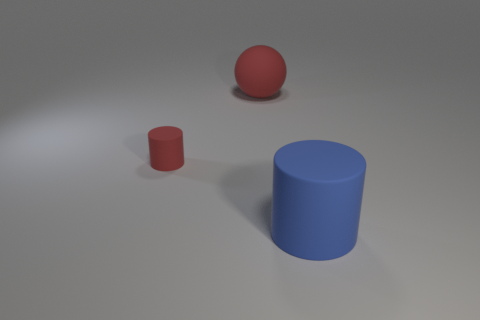Does the big cylinder have the same color as the tiny object?
Your response must be concise. No. There is a large rubber thing behind the rubber cylinder in front of the red matte cylinder; how many cylinders are right of it?
Your answer should be very brief. 1. There is a small red thing that is the same material as the sphere; what is its shape?
Keep it short and to the point. Cylinder. There is a large object behind the matte cylinder that is behind the matte cylinder that is right of the red matte ball; what is its material?
Make the answer very short. Rubber. What number of things are things on the left side of the large red rubber thing or small green shiny spheres?
Your answer should be compact. 1. What number of other things are there of the same shape as the large red matte object?
Your answer should be very brief. 0. Is the number of rubber cylinders to the left of the large ball greater than the number of tiny cyan rubber spheres?
Offer a terse response. Yes. There is another object that is the same shape as the tiny red rubber thing; what is its size?
Give a very brief answer. Large. What is the shape of the small rubber object?
Give a very brief answer. Cylinder. The blue rubber thing that is the same size as the red sphere is what shape?
Your answer should be compact. Cylinder. 